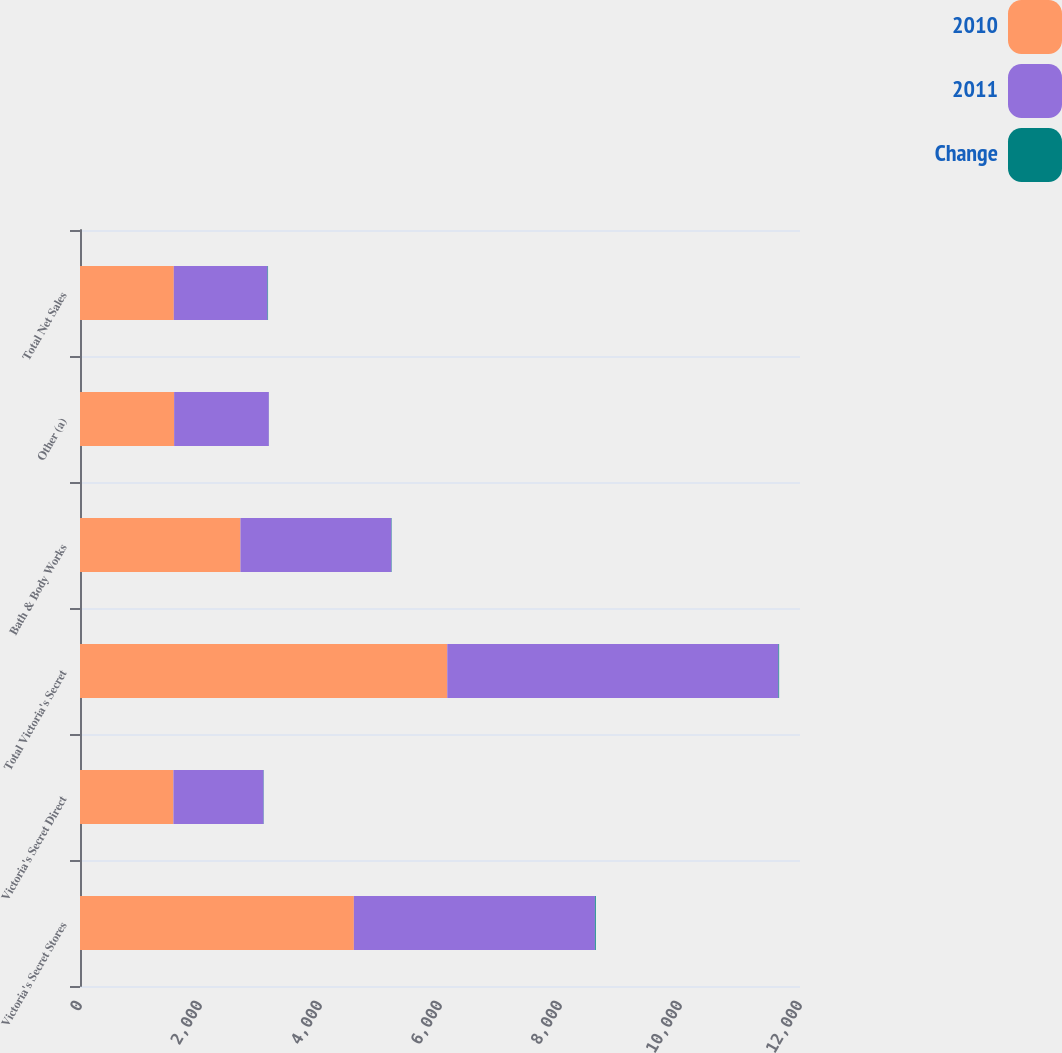Convert chart. <chart><loc_0><loc_0><loc_500><loc_500><stacked_bar_chart><ecel><fcel>Victoria's Secret Stores<fcel>Victoria's Secret Direct<fcel>Total Victoria's Secret<fcel>Bath & Body Works<fcel>Other (a)<fcel>Total Net Sales<nl><fcel>2010<fcel>4564<fcel>1557<fcel>6121<fcel>2674<fcel>1569<fcel>1563<nl><fcel>2011<fcel>4018<fcel>1502<fcel>5520<fcel>2515<fcel>1578<fcel>1563<nl><fcel>Change<fcel>14<fcel>4<fcel>11<fcel>6<fcel>1<fcel>8<nl></chart> 